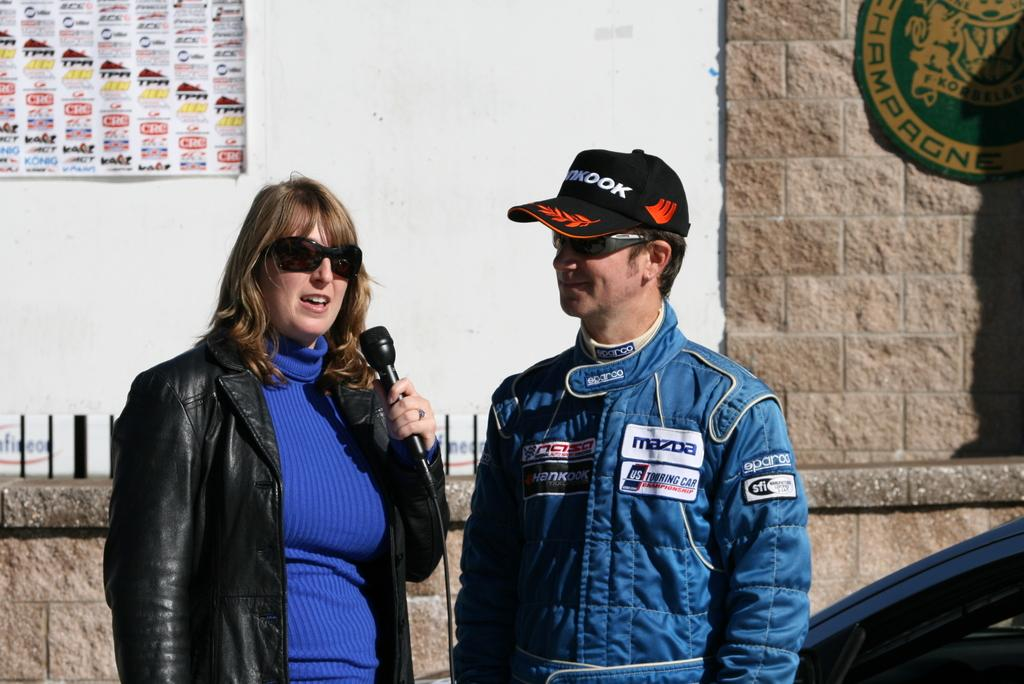<image>
Present a compact description of the photo's key features. A woman is intereviewing a man in a jacket with a Mazda badge on his chest. 